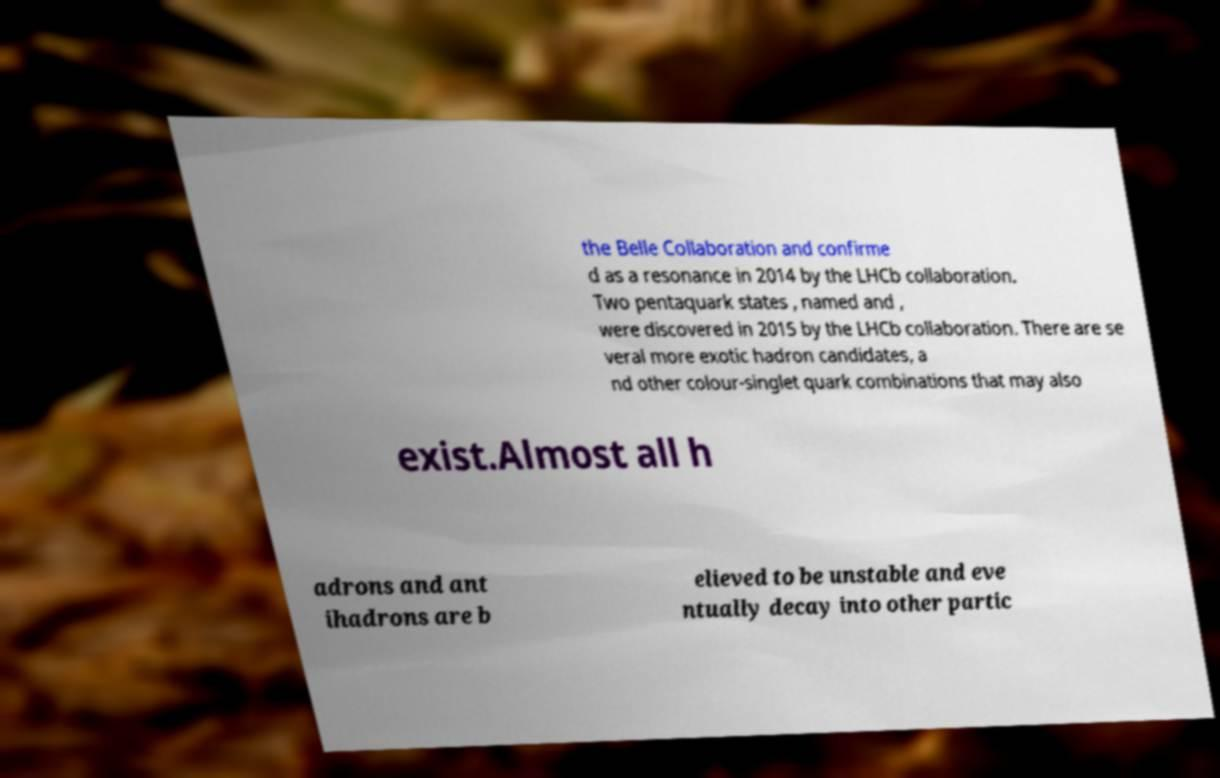Could you assist in decoding the text presented in this image and type it out clearly? the Belle Collaboration and confirme d as a resonance in 2014 by the LHCb collaboration. Two pentaquark states , named and , were discovered in 2015 by the LHCb collaboration. There are se veral more exotic hadron candidates, a nd other colour-singlet quark combinations that may also exist.Almost all h adrons and ant ihadrons are b elieved to be unstable and eve ntually decay into other partic 